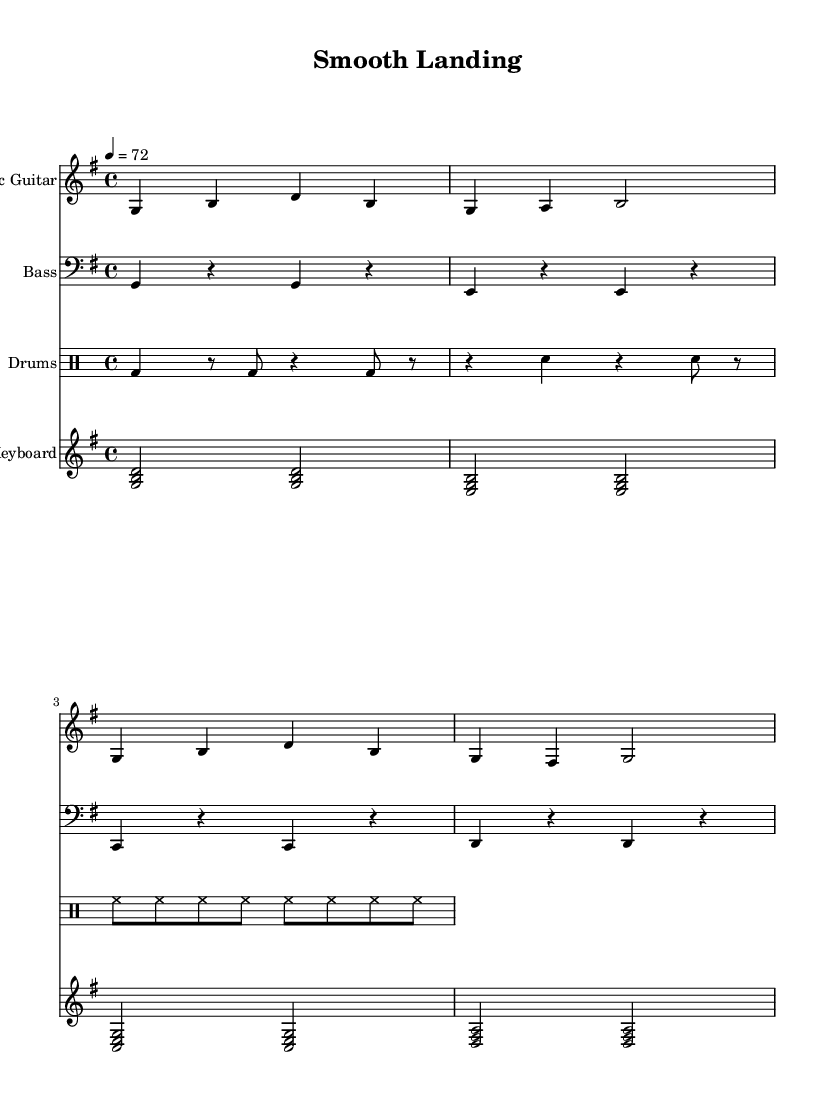What is the key signature of this music? The key signature is G major, which has one sharp (F#). This can be determined by looking at the key signature placed at the beginning of the staff.
Answer: G major What is the time signature of this piece? The time signature is 4/4, indicated at the beginning of the sheet music. This means there are four beats in each measure and the quarter note gets one beat.
Answer: 4/4 What is the tempo marking for this piece? The tempo marking is 72, which indicates the speed of 72 beats per minute. This is explicitly shown in the tempo indication provided in the score.
Answer: 72 How many measures are in the electric guitar part? The electric guitar part contains four measures, which can be counted by looking at the notation provided for the electric guitar part.
Answer: 4 What instruments are featured in this piece? The featured instruments include electric guitar, bass, drums, and keyboard. This can be determined by examining the instrument names listed above each staff in the score.
Answer: Electric guitar, bass, drums, keyboard What is the relationship between the bass and electric guitar parts? The bass guitar typically provides the foundational rhythmic and harmonic structure, while the electric guitar plays melodic lines on top of that. When analyzing both parts, you can see that they complement each other with contrasting rhythmic patterns and harmonies.
Answer: Complementary What rhythmic characteristic is common in reggae music, as represented in this score? A common rhythmic characteristic in reggae music is the emphasis on the second and fourth beats (backbeat), as shown by the drum patterns in the piece, especially in the snare drum. This backbeat can be observed in the drumming notation.
Answer: Backbeat 